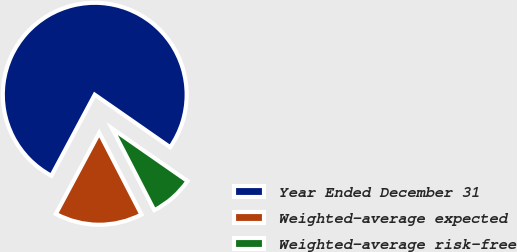<chart> <loc_0><loc_0><loc_500><loc_500><pie_chart><fcel>Year Ended December 31<fcel>Weighted-average expected<fcel>Weighted-average risk-free<nl><fcel>76.86%<fcel>15.41%<fcel>7.73%<nl></chart> 